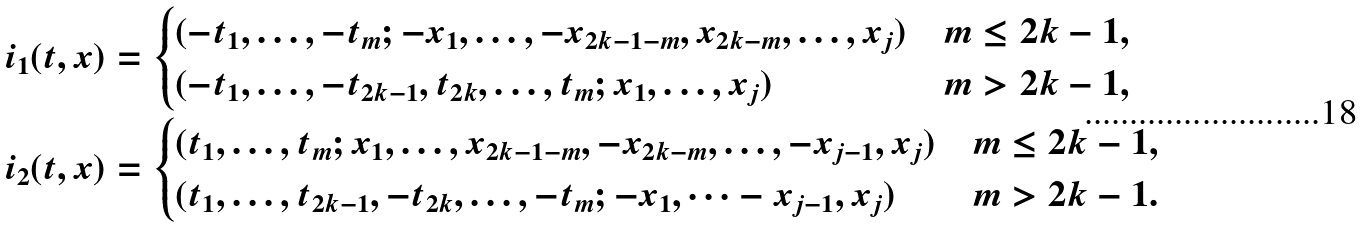Convert formula to latex. <formula><loc_0><loc_0><loc_500><loc_500>i _ { 1 } ( t , x ) & = \begin{cases} ( - t _ { 1 } , \dots , - t _ { m } ; - x _ { 1 } , \dots , - x _ { 2 k - 1 - m } , x _ { 2 k - m } , \dots , x _ { j } ) & m \leq 2 k - 1 , \\ ( - t _ { 1 } , \dots , - t _ { 2 k - 1 } , t _ { 2 k } , \dots , t _ { m } ; x _ { 1 } , \dots , x _ { j } ) & m > 2 k - 1 , \end{cases} \\ i _ { 2 } ( t , x ) & = \begin{cases} ( t _ { 1 } , \dots , t _ { m } ; x _ { 1 } , \dots , x _ { 2 k - 1 - m } , - x _ { 2 k - m } , \dots , - x _ { j - 1 } , x _ { j } ) & m \leq 2 k - 1 , \\ ( t _ { 1 } , \dots , t _ { 2 k - 1 } , - t _ { 2 k } , \dots , - t _ { m } ; - x _ { 1 } , \dots - x _ { j - 1 } , x _ { j } ) & m > 2 k - 1 . \end{cases}</formula> 